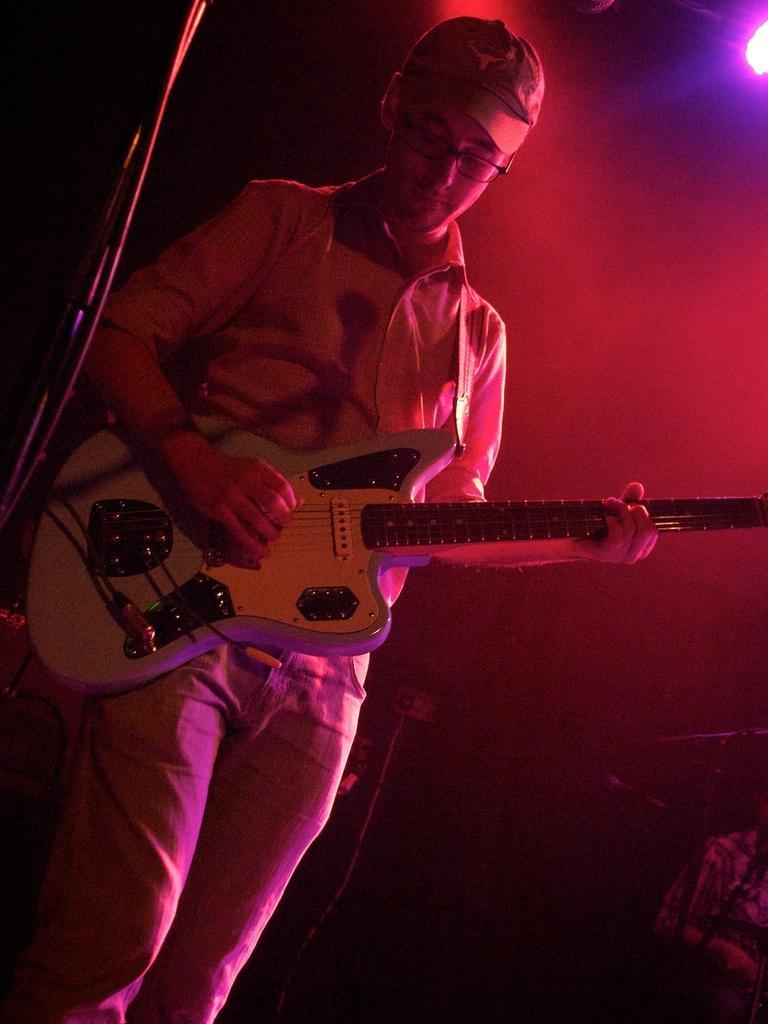Can you describe this image briefly? In this picture a man is holding the guitar with his left hand and playing the guitar with his right hand. He has wore a cap and he has spectacles. There are disco lights attached to the ceiling. 